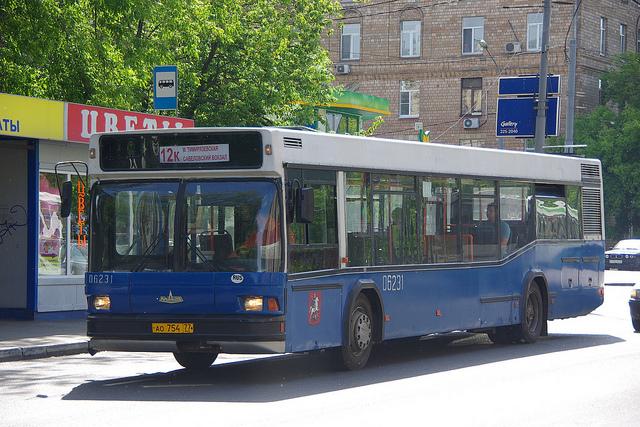What is the buses maker?
Quick response, please. Unknown. How many buses are there?
Concise answer only. 1. Is the bus blue?
Short answer required. Yes. How many wheels can you see on the bus?
Quick response, please. 4. Are there passengers on the bus?
Write a very short answer. Yes. What color is the bus?
Quick response, please. Blue. What says in front of the bus?
Be succinct. 06231. Does the bus have at least one rider?
Be succinct. Yes. 